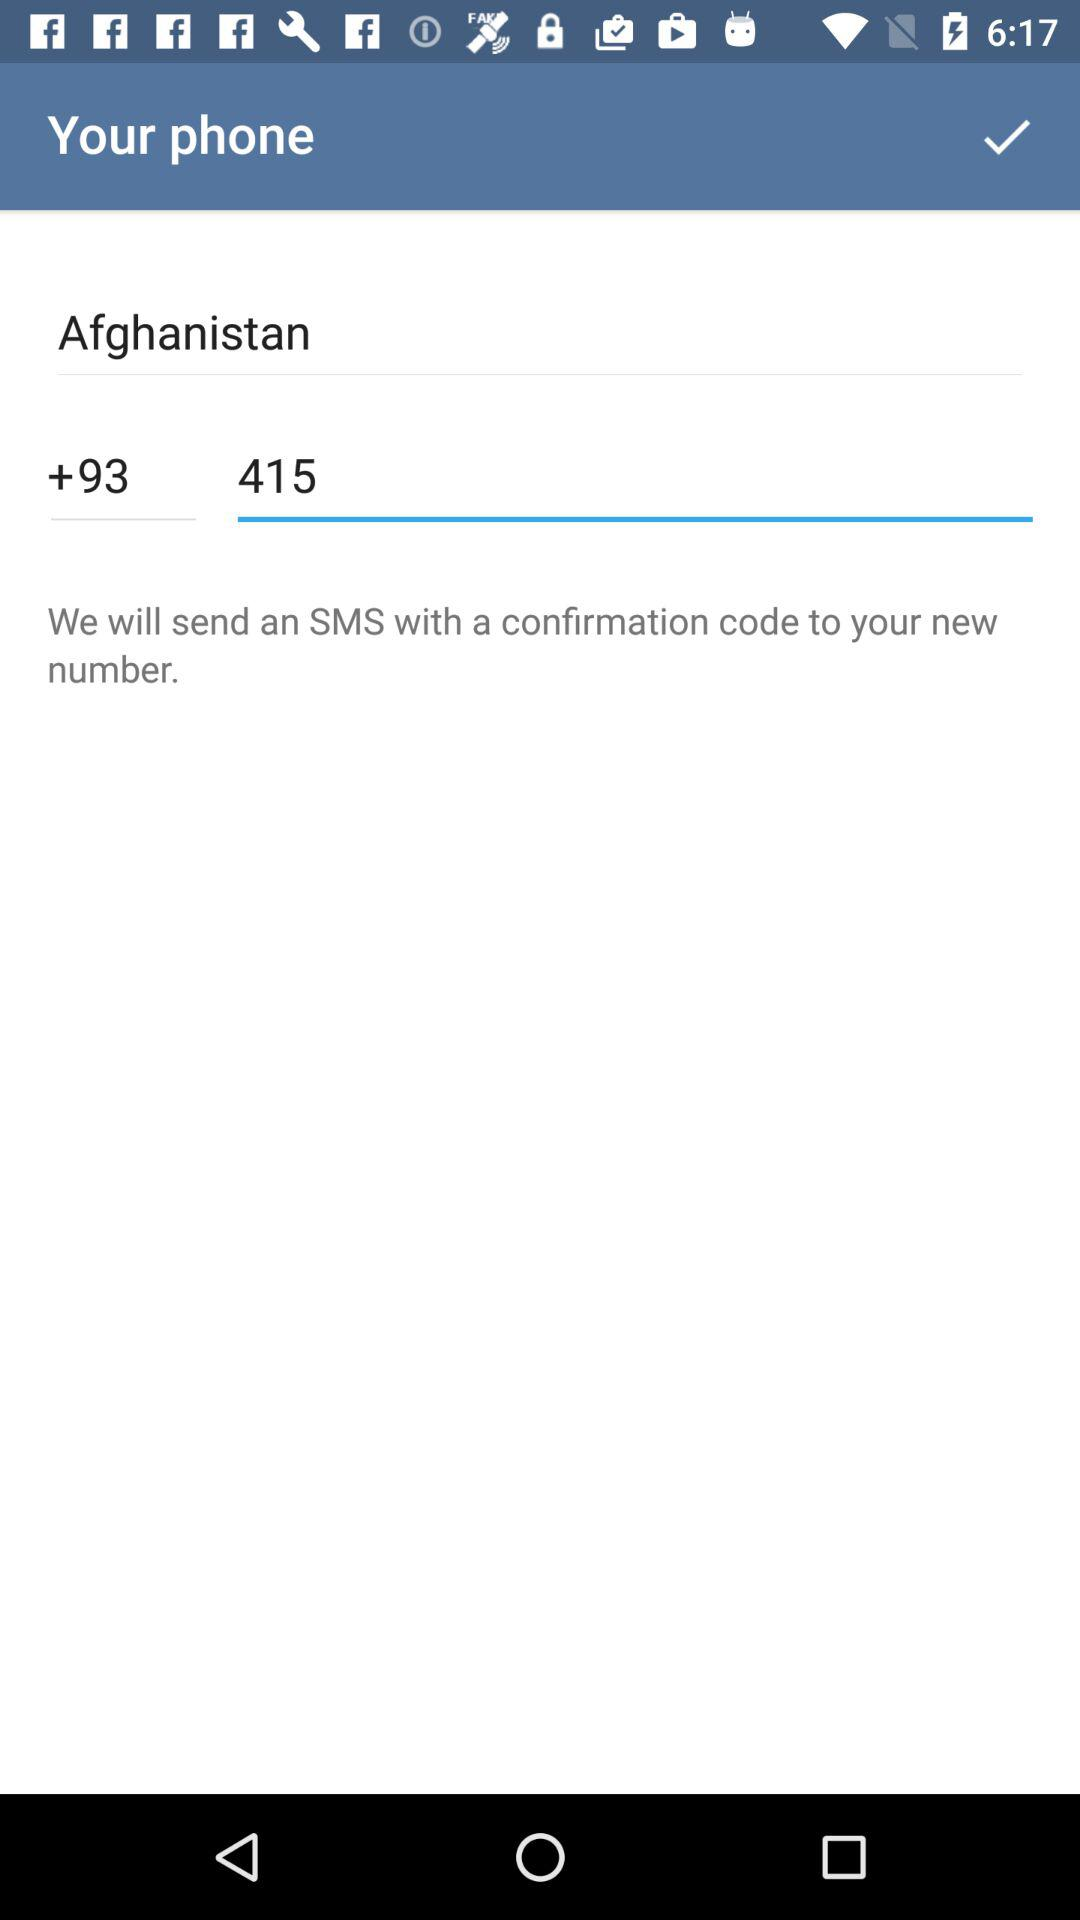What is the entered phone number? The entered phone number is "415". 